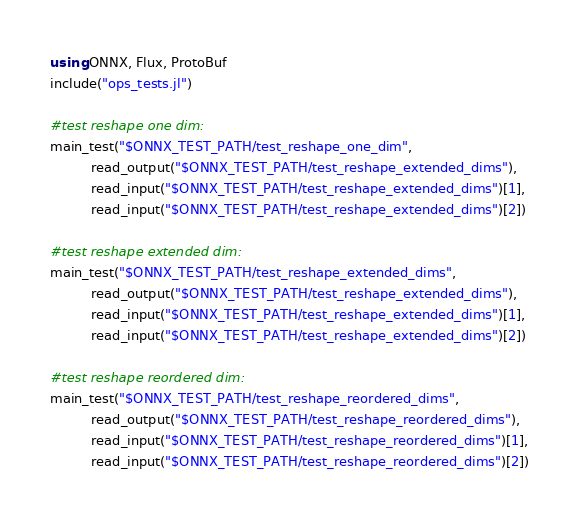<code> <loc_0><loc_0><loc_500><loc_500><_Julia_>using ONNX, Flux, ProtoBuf
include("ops_tests.jl")

#test reshape one dim:
main_test("$ONNX_TEST_PATH/test_reshape_one_dim", 
          read_output("$ONNX_TEST_PATH/test_reshape_extended_dims"),
          read_input("$ONNX_TEST_PATH/test_reshape_extended_dims")[1],
          read_input("$ONNX_TEST_PATH/test_reshape_extended_dims")[2])

#test reshape extended dim:
main_test("$ONNX_TEST_PATH/test_reshape_extended_dims", 
          read_output("$ONNX_TEST_PATH/test_reshape_extended_dims"),
          read_input("$ONNX_TEST_PATH/test_reshape_extended_dims")[1], 
          read_input("$ONNX_TEST_PATH/test_reshape_extended_dims")[2])

#test reshape reordered dim:
main_test("$ONNX_TEST_PATH/test_reshape_reordered_dims", 
          read_output("$ONNX_TEST_PATH/test_reshape_reordered_dims"), 
          read_input("$ONNX_TEST_PATH/test_reshape_reordered_dims")[1], 
          read_input("$ONNX_TEST_PATH/test_reshape_reordered_dims")[2])
</code> 